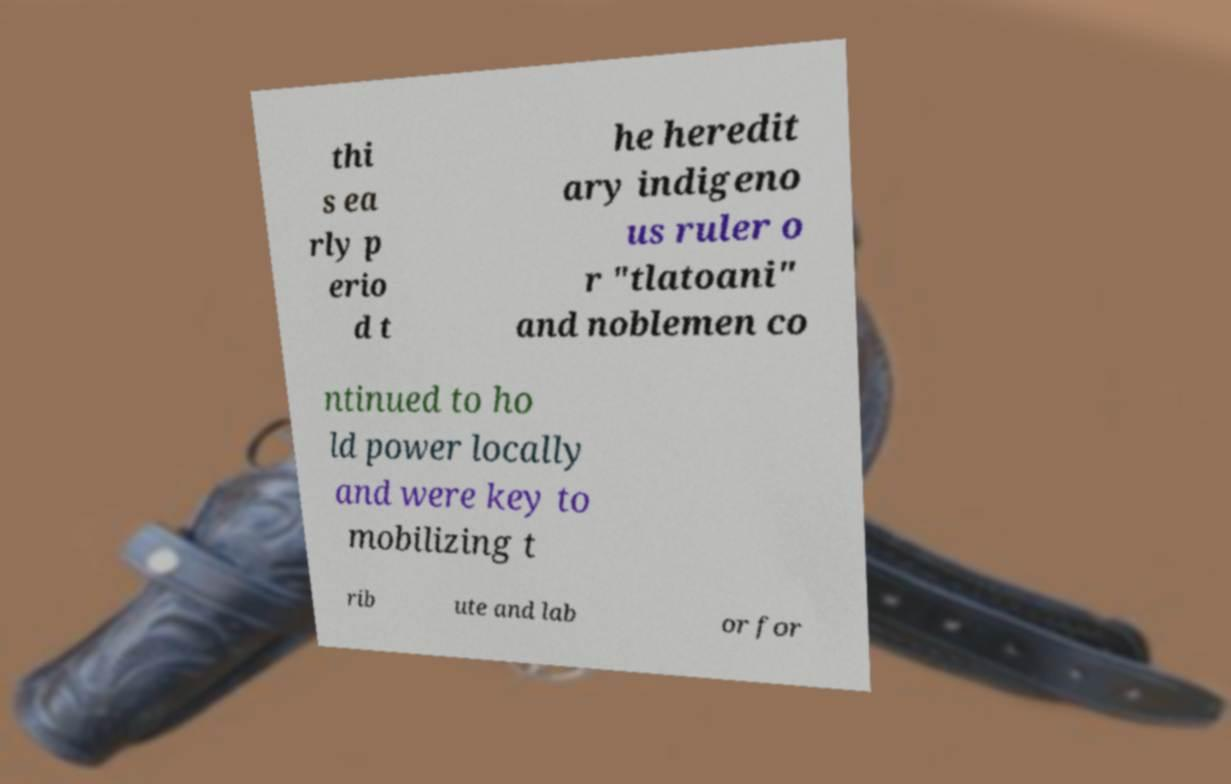Please identify and transcribe the text found in this image. thi s ea rly p erio d t he heredit ary indigeno us ruler o r "tlatoani" and noblemen co ntinued to ho ld power locally and were key to mobilizing t rib ute and lab or for 